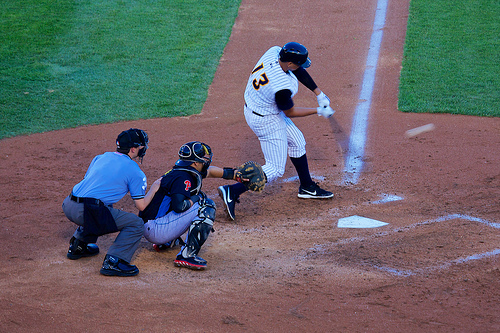Who is the player in front of? The player at bat is directly in front of the umpire, who is keeping a close watch on the play. 